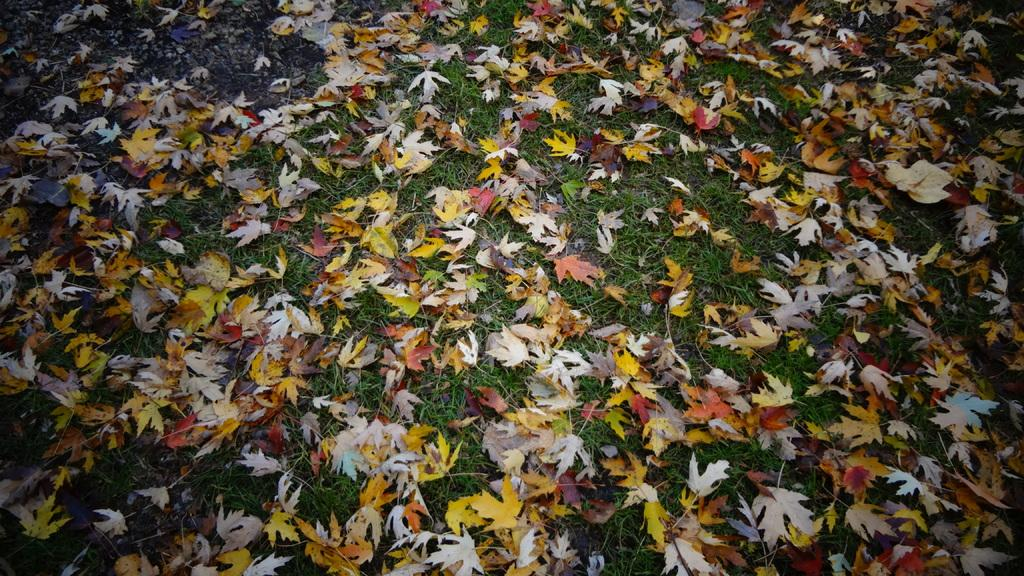What type of vegetation is present in the image? The image contains grass. What other natural elements can be seen in the image? There are leaves in the image. What colors are the leaves? The leaves are in yellow and white color. What type of rail can be seen in the image? There is no rail present in the image. How much juice can be squeezed from the leaves in the image? The leaves in the image are not fruit or vegetable, so they cannot be squeezed for juice. 